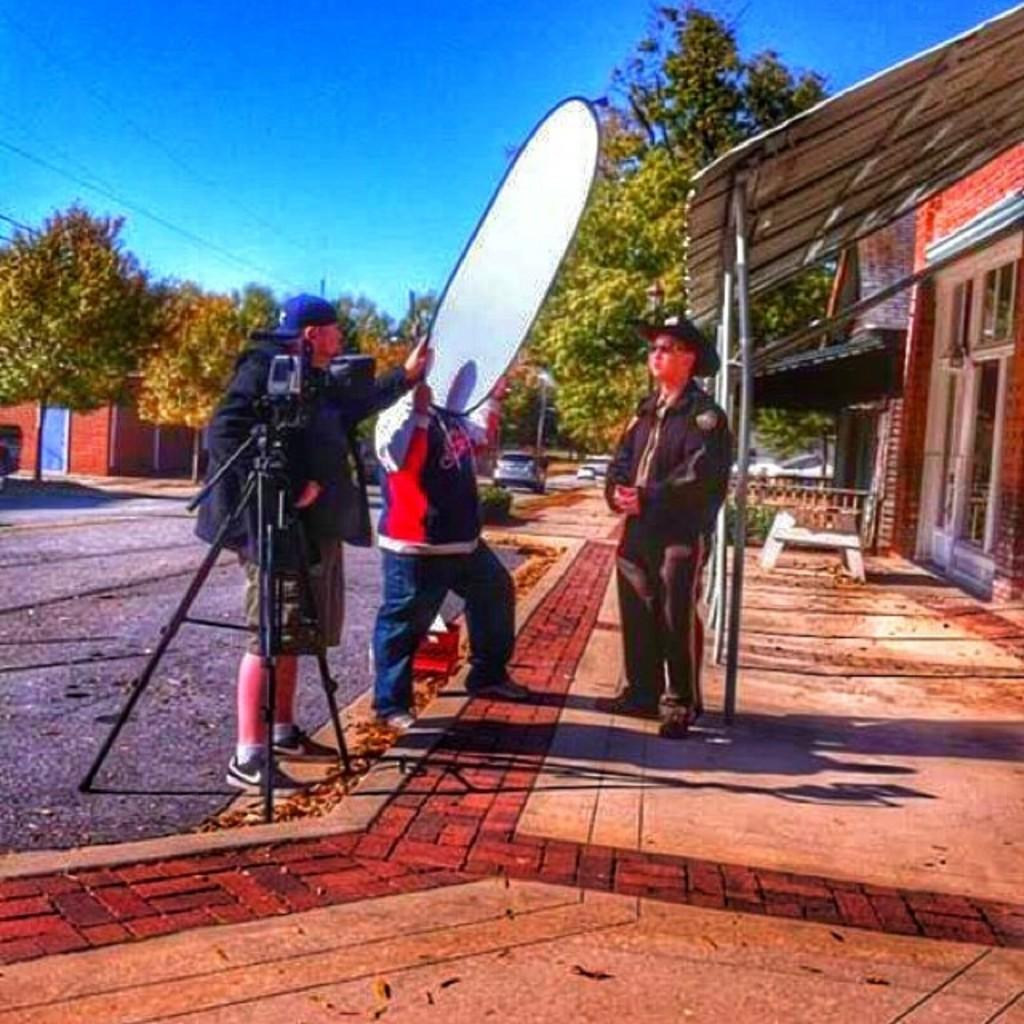How many people are in the image? There are three persons in the image. What else can be seen in the image besides the people? There are cars on the road, a camera, trees, a house, and the sky visible in the background of the image. What type of butter is being used to grease the camera lens in the image? There is no butter present in the image, and the camera lens does not appear to be greased. 